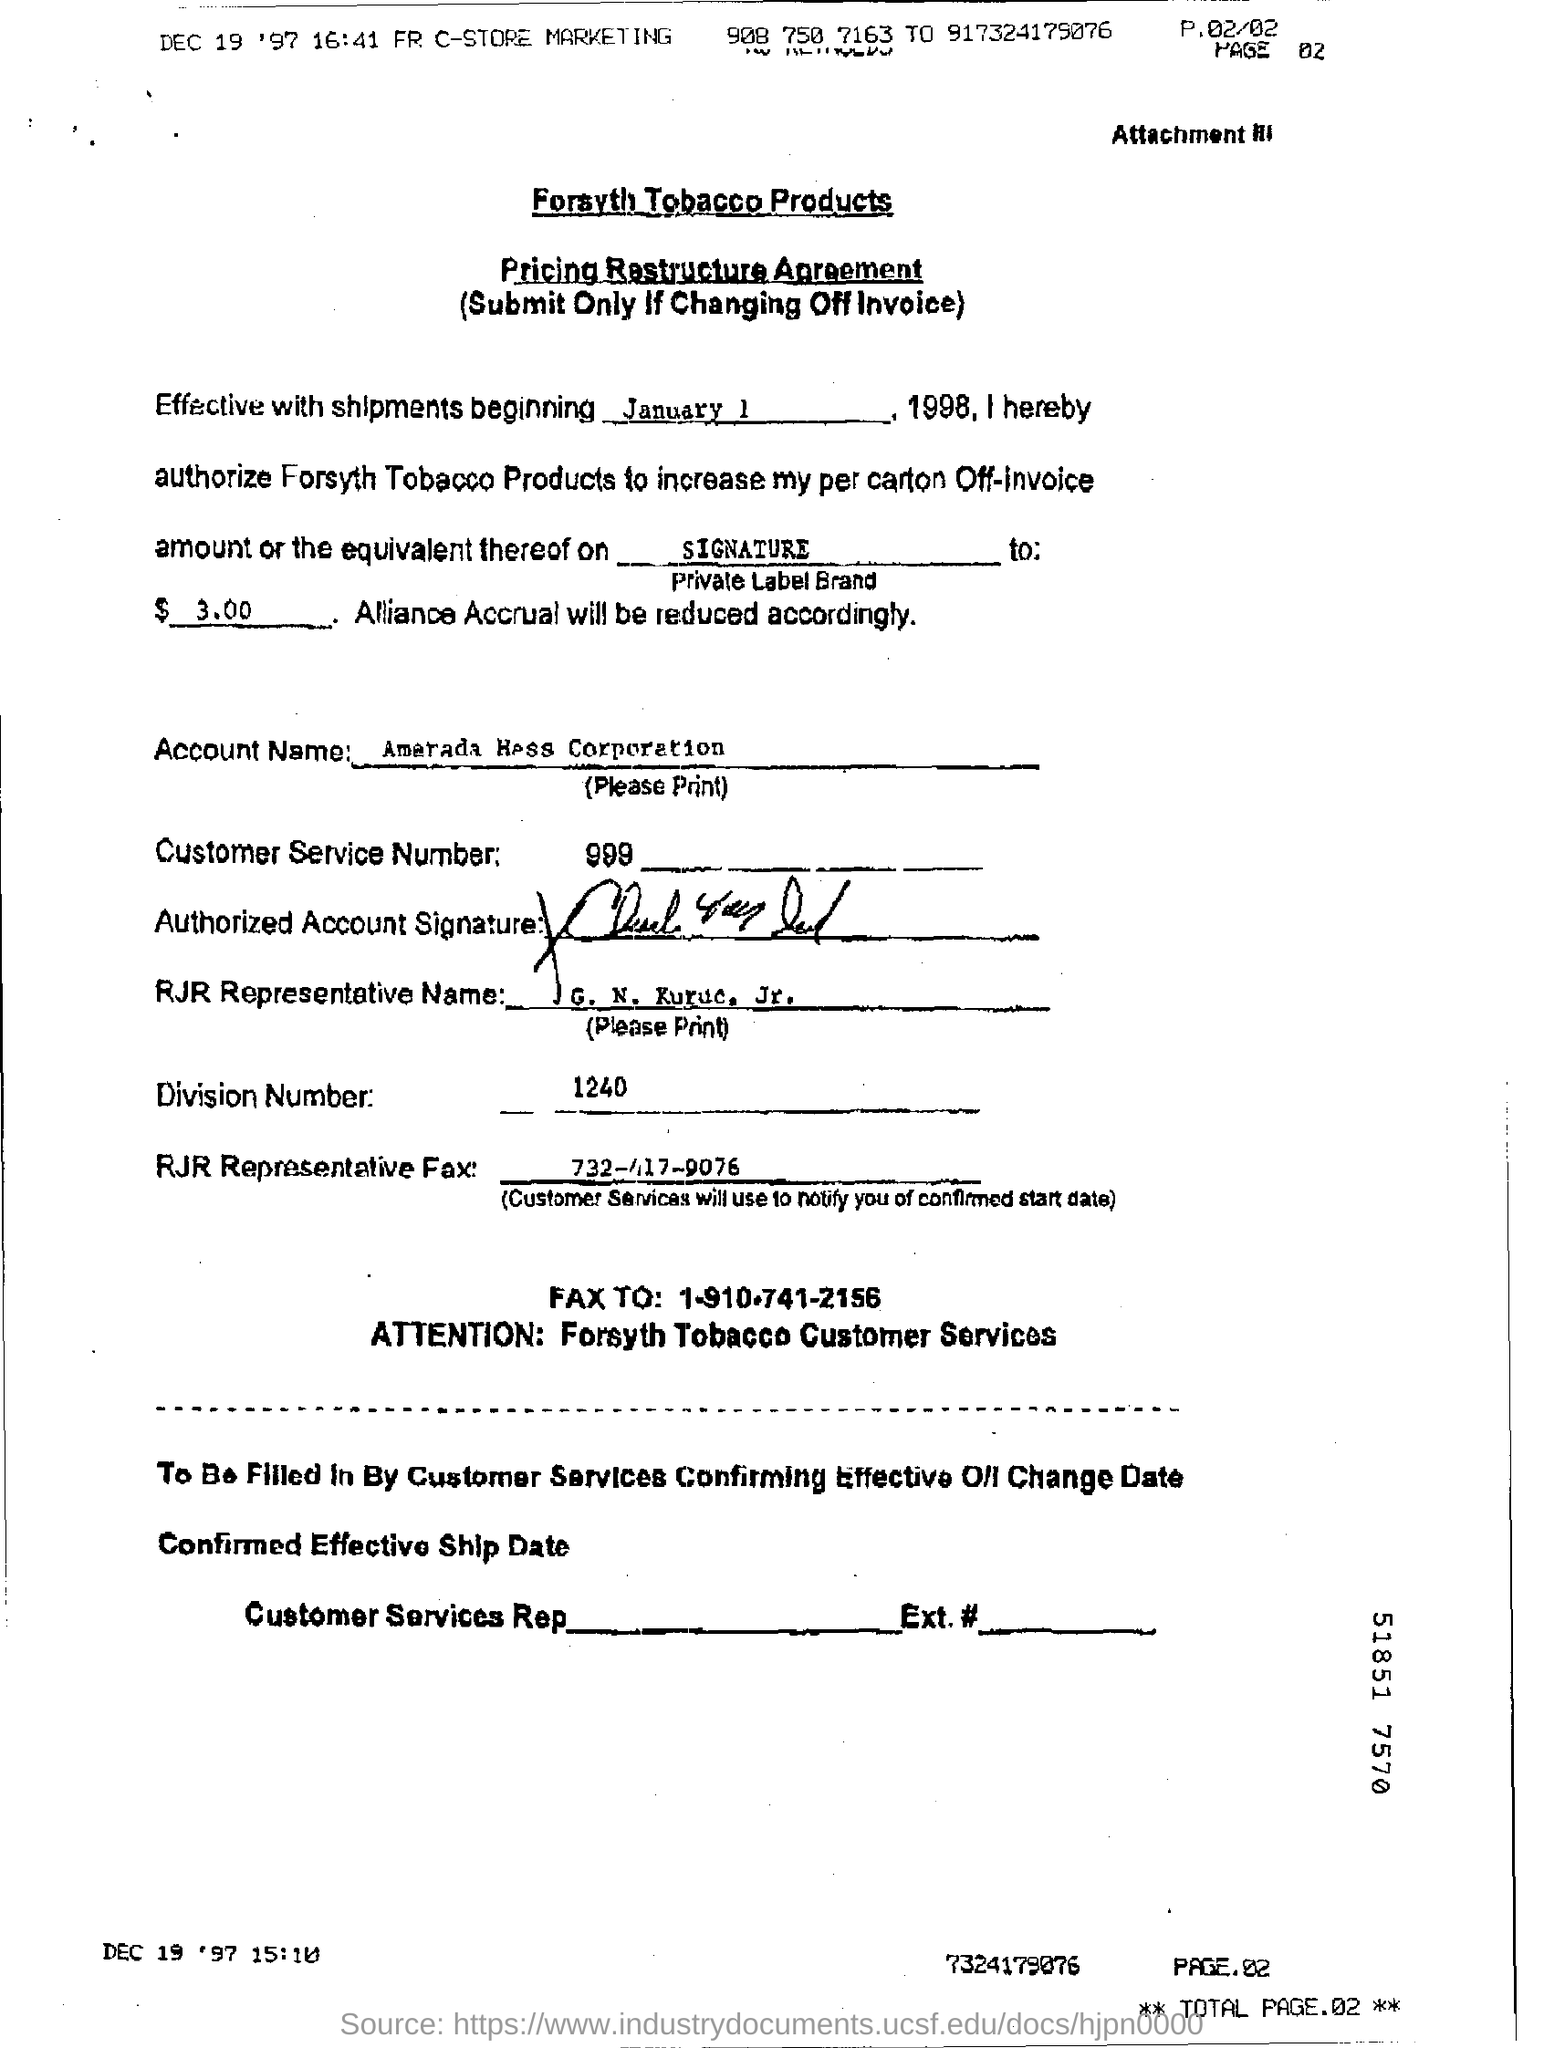Outline some significant characteristics in this image. The custom service number is 999... Shipping will begin on January 1. The division number is 1240. The agreement concerns the pricing restructure. The product name is Forsyth Tobacco Products. 